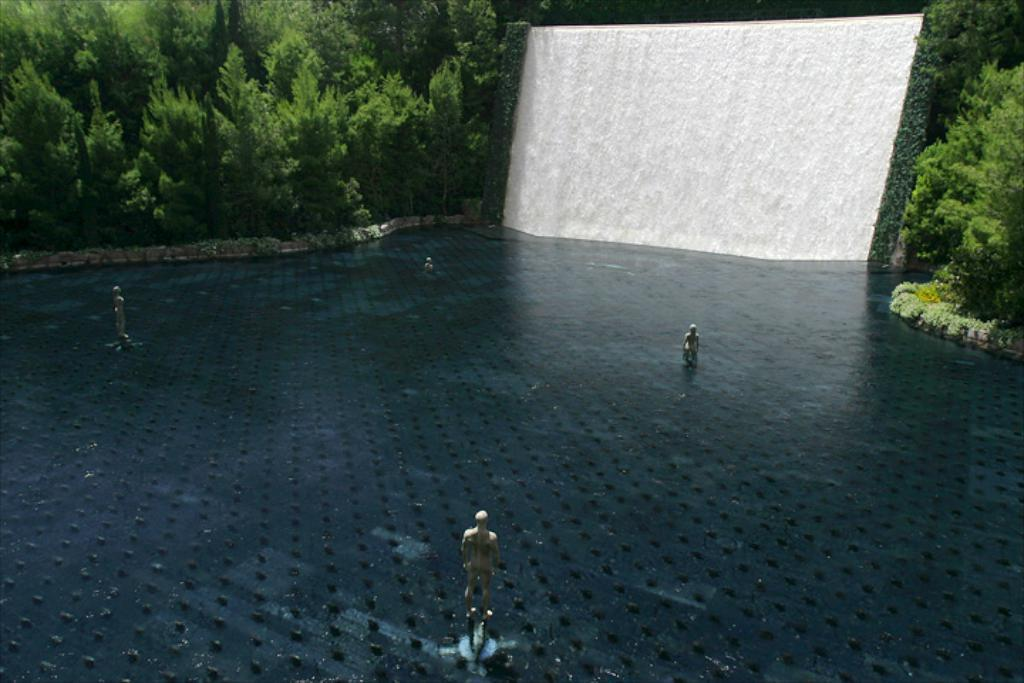What is located in the water in the image? There are statues in the water in the image. What can be seen in the background of the image? There are trees and a waterfall visible in the background of the image. What type of footwear is the zebra wearing in the image? There is no zebra present in the image, so it is not possible to determine what type of footwear it might be wearing. 